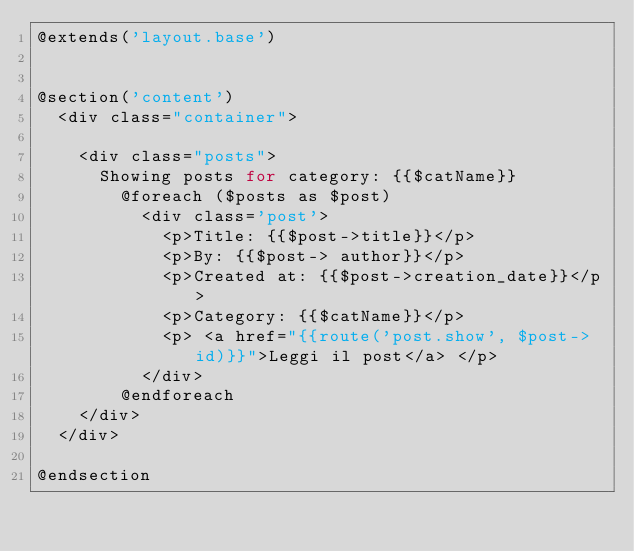Convert code to text. <code><loc_0><loc_0><loc_500><loc_500><_PHP_>@extends('layout.base')


@section('content')
  <div class="container">

    <div class="posts">
      Showing posts for category: {{$catName}}
        @foreach ($posts as $post)
          <div class='post'>
            <p>Title: {{$post->title}}</p>
            <p>By: {{$post-> author}}</p>
            <p>Created at: {{$post->creation_date}}</p>
            <p>Category: {{$catName}}</p>
            <p> <a href="{{route('post.show', $post->id)}}">Leggi il post</a> </p>
          </div>
        @endforeach
    </div>
  </div>

@endsection
</code> 